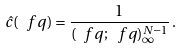Convert formula to latex. <formula><loc_0><loc_0><loc_500><loc_500>\hat { c } ( \ f q ) = \frac { 1 } { ( \ f q ; \ f q ) _ { \infty } ^ { N - 1 } } \, .</formula> 